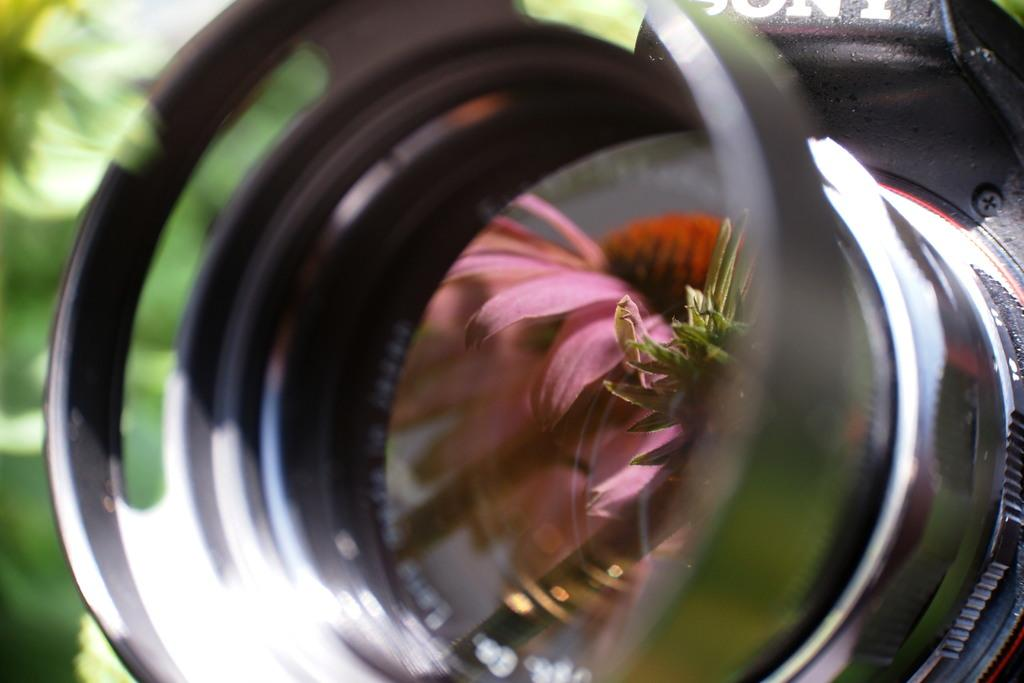What is the main object in the image? There is a camera with a lens in the image. What can be seen in the reflection of the camera's lens? There is a reflection of a flower in the center of the image. Where is the fowl perched in the image? There is no fowl present in the image. What type of shelf can be seen holding the camera in the image? There is no shelf visible in the image; the camera is not resting on any surface. 